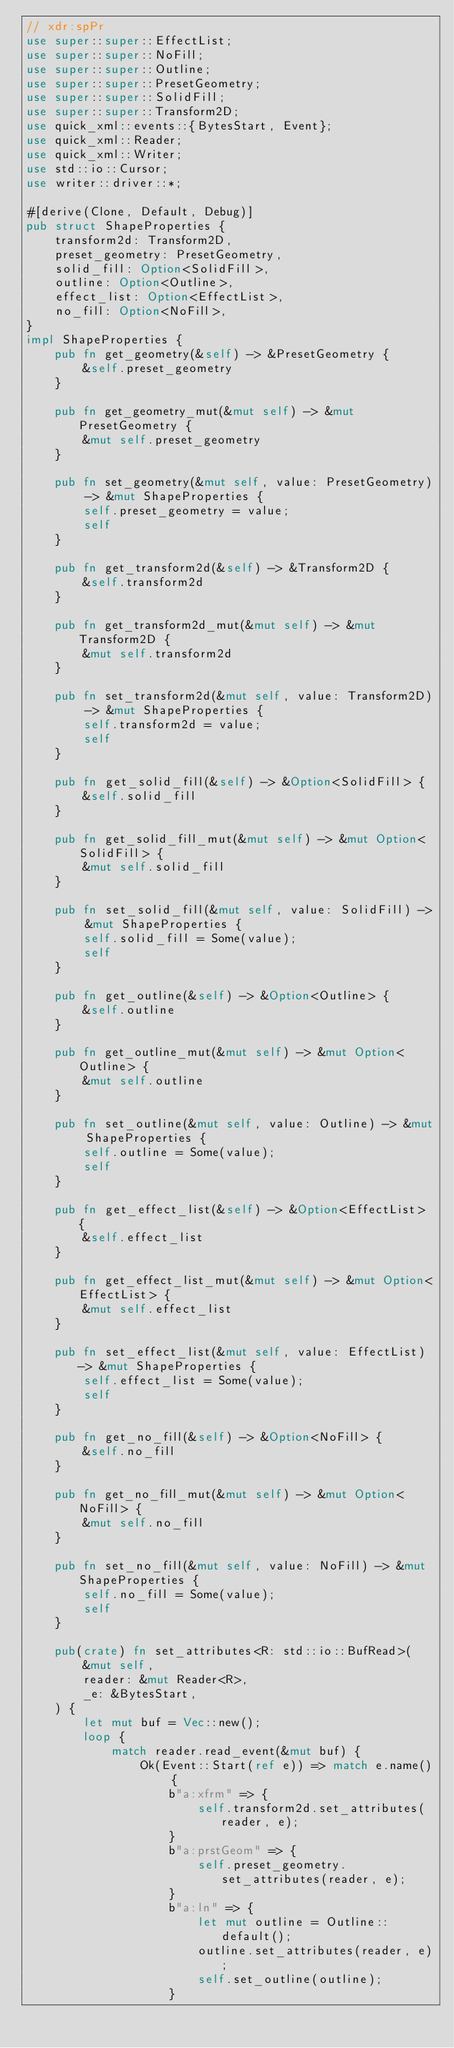Convert code to text. <code><loc_0><loc_0><loc_500><loc_500><_Rust_>// xdr:spPr
use super::super::EffectList;
use super::super::NoFill;
use super::super::Outline;
use super::super::PresetGeometry;
use super::super::SolidFill;
use super::super::Transform2D;
use quick_xml::events::{BytesStart, Event};
use quick_xml::Reader;
use quick_xml::Writer;
use std::io::Cursor;
use writer::driver::*;

#[derive(Clone, Default, Debug)]
pub struct ShapeProperties {
    transform2d: Transform2D,
    preset_geometry: PresetGeometry,
    solid_fill: Option<SolidFill>,
    outline: Option<Outline>,
    effect_list: Option<EffectList>,
    no_fill: Option<NoFill>,
}
impl ShapeProperties {
    pub fn get_geometry(&self) -> &PresetGeometry {
        &self.preset_geometry
    }

    pub fn get_geometry_mut(&mut self) -> &mut PresetGeometry {
        &mut self.preset_geometry
    }

    pub fn set_geometry(&mut self, value: PresetGeometry) -> &mut ShapeProperties {
        self.preset_geometry = value;
        self
    }

    pub fn get_transform2d(&self) -> &Transform2D {
        &self.transform2d
    }

    pub fn get_transform2d_mut(&mut self) -> &mut Transform2D {
        &mut self.transform2d
    }

    pub fn set_transform2d(&mut self, value: Transform2D) -> &mut ShapeProperties {
        self.transform2d = value;
        self
    }

    pub fn get_solid_fill(&self) -> &Option<SolidFill> {
        &self.solid_fill
    }

    pub fn get_solid_fill_mut(&mut self) -> &mut Option<SolidFill> {
        &mut self.solid_fill
    }

    pub fn set_solid_fill(&mut self, value: SolidFill) -> &mut ShapeProperties {
        self.solid_fill = Some(value);
        self
    }

    pub fn get_outline(&self) -> &Option<Outline> {
        &self.outline
    }

    pub fn get_outline_mut(&mut self) -> &mut Option<Outline> {
        &mut self.outline
    }

    pub fn set_outline(&mut self, value: Outline) -> &mut ShapeProperties {
        self.outline = Some(value);
        self
    }

    pub fn get_effect_list(&self) -> &Option<EffectList> {
        &self.effect_list
    }

    pub fn get_effect_list_mut(&mut self) -> &mut Option<EffectList> {
        &mut self.effect_list
    }

    pub fn set_effect_list(&mut self, value: EffectList) -> &mut ShapeProperties {
        self.effect_list = Some(value);
        self
    }

    pub fn get_no_fill(&self) -> &Option<NoFill> {
        &self.no_fill
    }

    pub fn get_no_fill_mut(&mut self) -> &mut Option<NoFill> {
        &mut self.no_fill
    }

    pub fn set_no_fill(&mut self, value: NoFill) -> &mut ShapeProperties {
        self.no_fill = Some(value);
        self
    }

    pub(crate) fn set_attributes<R: std::io::BufRead>(
        &mut self,
        reader: &mut Reader<R>,
        _e: &BytesStart,
    ) {
        let mut buf = Vec::new();
        loop {
            match reader.read_event(&mut buf) {
                Ok(Event::Start(ref e)) => match e.name() {
                    b"a:xfrm" => {
                        self.transform2d.set_attributes(reader, e);
                    }
                    b"a:prstGeom" => {
                        self.preset_geometry.set_attributes(reader, e);
                    }
                    b"a:ln" => {
                        let mut outline = Outline::default();
                        outline.set_attributes(reader, e);
                        self.set_outline(outline);
                    }</code> 